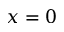Convert formula to latex. <formula><loc_0><loc_0><loc_500><loc_500>x = 0</formula> 